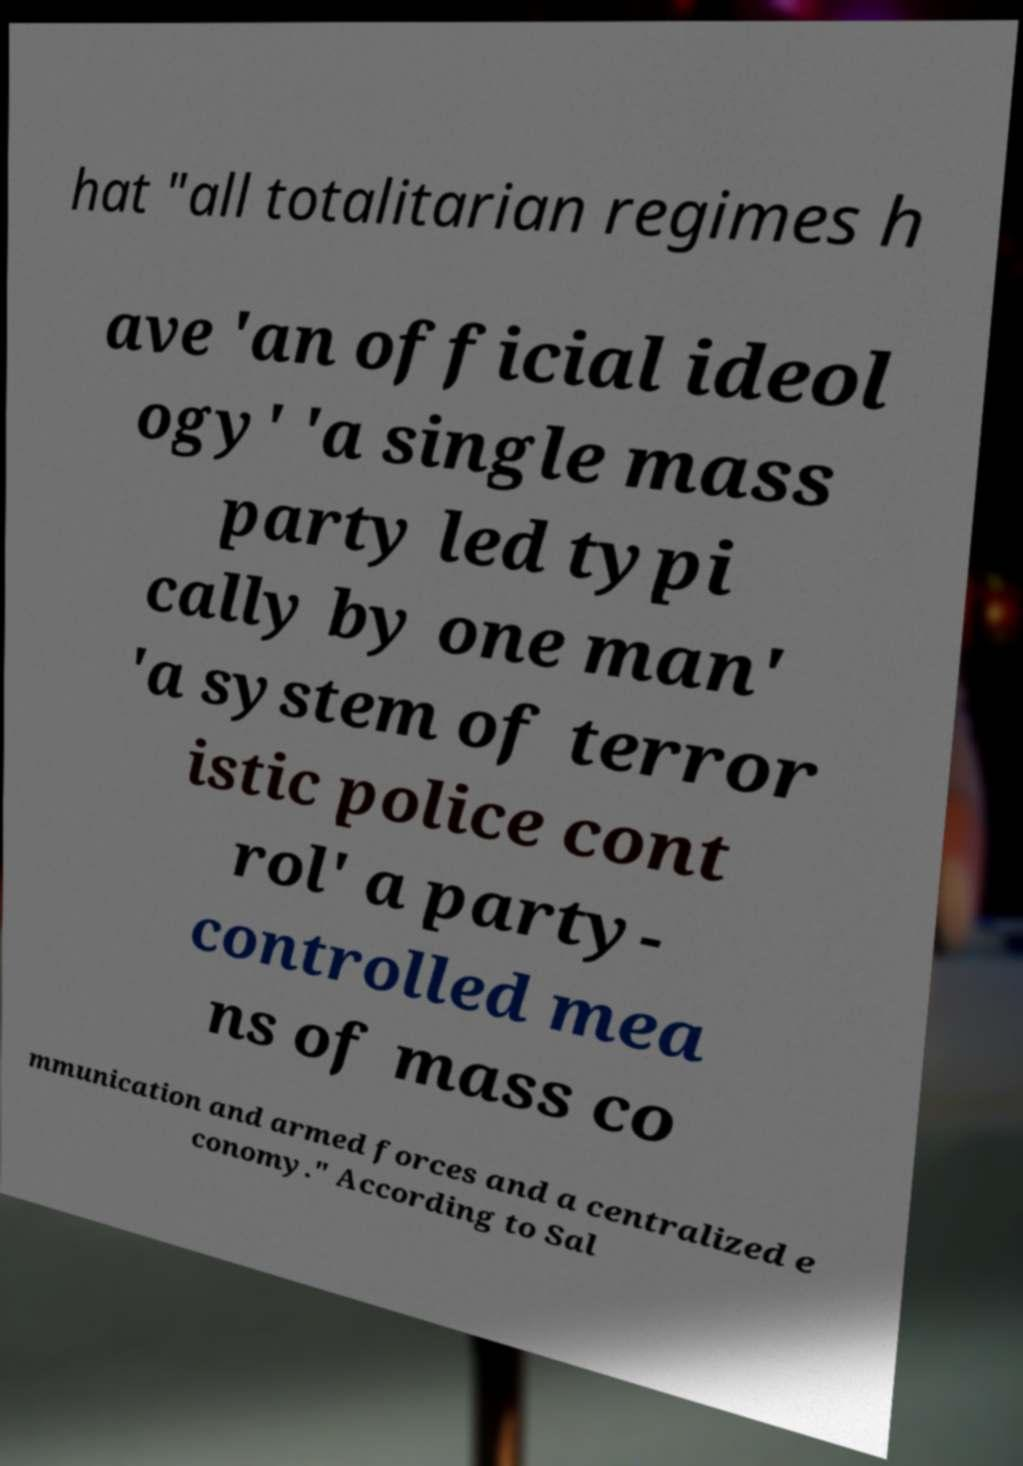Could you assist in decoding the text presented in this image and type it out clearly? hat "all totalitarian regimes h ave 'an official ideol ogy' 'a single mass party led typi cally by one man' 'a system of terror istic police cont rol' a party- controlled mea ns of mass co mmunication and armed forces and a centralized e conomy." According to Sal 